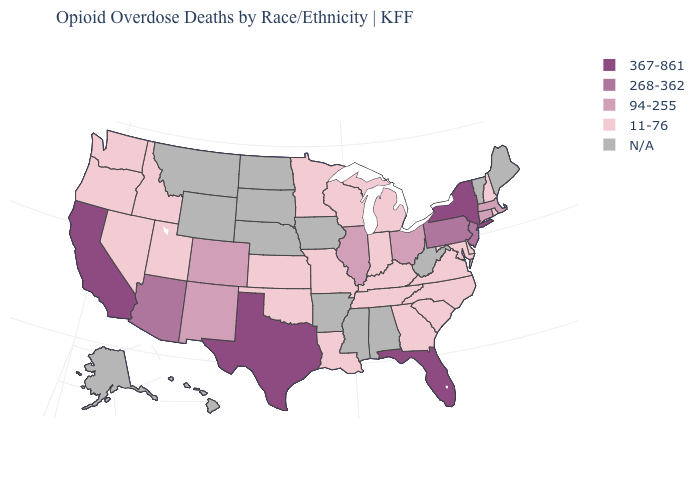Among the states that border Virginia , which have the lowest value?
Concise answer only. Kentucky, Maryland, North Carolina, Tennessee. What is the value of Idaho?
Write a very short answer. 11-76. What is the value of Missouri?
Answer briefly. 11-76. What is the value of Rhode Island?
Write a very short answer. 11-76. What is the highest value in the South ?
Write a very short answer. 367-861. Which states have the lowest value in the West?
Keep it brief. Idaho, Nevada, Oregon, Utah, Washington. Does New Hampshire have the lowest value in the Northeast?
Short answer required. Yes. Does the first symbol in the legend represent the smallest category?
Quick response, please. No. What is the highest value in states that border Louisiana?
Quick response, please. 367-861. Does the first symbol in the legend represent the smallest category?
Quick response, please. No. Which states have the highest value in the USA?
Short answer required. California, Florida, New York, Texas. Among the states that border Delaware , does Maryland have the highest value?
Keep it brief. No. Which states have the lowest value in the MidWest?
Keep it brief. Indiana, Kansas, Michigan, Minnesota, Missouri, Wisconsin. Does Missouri have the highest value in the USA?
Give a very brief answer. No. 